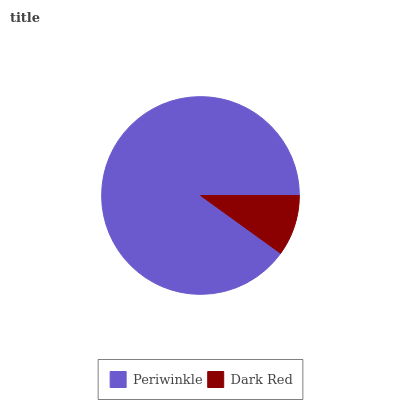Is Dark Red the minimum?
Answer yes or no. Yes. Is Periwinkle the maximum?
Answer yes or no. Yes. Is Dark Red the maximum?
Answer yes or no. No. Is Periwinkle greater than Dark Red?
Answer yes or no. Yes. Is Dark Red less than Periwinkle?
Answer yes or no. Yes. Is Dark Red greater than Periwinkle?
Answer yes or no. No. Is Periwinkle less than Dark Red?
Answer yes or no. No. Is Periwinkle the high median?
Answer yes or no. Yes. Is Dark Red the low median?
Answer yes or no. Yes. Is Dark Red the high median?
Answer yes or no. No. Is Periwinkle the low median?
Answer yes or no. No. 